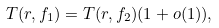Convert formula to latex. <formula><loc_0><loc_0><loc_500><loc_500>T ( r , f _ { 1 } ) = T ( r , f _ { 2 } ) ( 1 + o ( 1 ) ) ,</formula> 